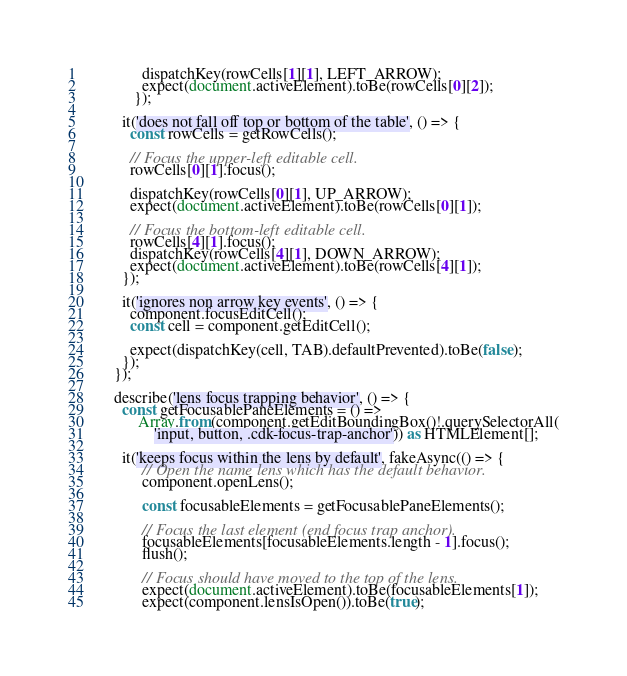Convert code to text. <code><loc_0><loc_0><loc_500><loc_500><_TypeScript_>               dispatchKey(rowCells[1][1], LEFT_ARROW);
               expect(document.activeElement).toBe(rowCells[0][2]);
             });

          it('does not fall off top or bottom of the table', () => {
            const rowCells = getRowCells();

            // Focus the upper-left editable cell.
            rowCells[0][1].focus();

            dispatchKey(rowCells[0][1], UP_ARROW);
            expect(document.activeElement).toBe(rowCells[0][1]);

            // Focus the bottom-left editable cell.
            rowCells[4][1].focus();
            dispatchKey(rowCells[4][1], DOWN_ARROW);
            expect(document.activeElement).toBe(rowCells[4][1]);
          });

          it('ignores non arrow key events', () => {
            component.focusEditCell();
            const cell = component.getEditCell();

            expect(dispatchKey(cell, TAB).defaultPrevented).toBe(false);
          });
        });

        describe('lens focus trapping behavior', () => {
          const getFocusablePaneElements = () =>
              Array.from(component.getEditBoundingBox()!.querySelectorAll(
                  'input, button, .cdk-focus-trap-anchor')) as HTMLElement[];

          it('keeps focus within the lens by default', fakeAsync(() => {
               // Open the name lens which has the default behavior.
               component.openLens();

               const focusableElements = getFocusablePaneElements();

               // Focus the last element (end focus trap anchor).
               focusableElements[focusableElements.length - 1].focus();
               flush();

               // Focus should have moved to the top of the lens.
               expect(document.activeElement).toBe(focusableElements[1]);
               expect(component.lensIsOpen()).toBe(true);</code> 